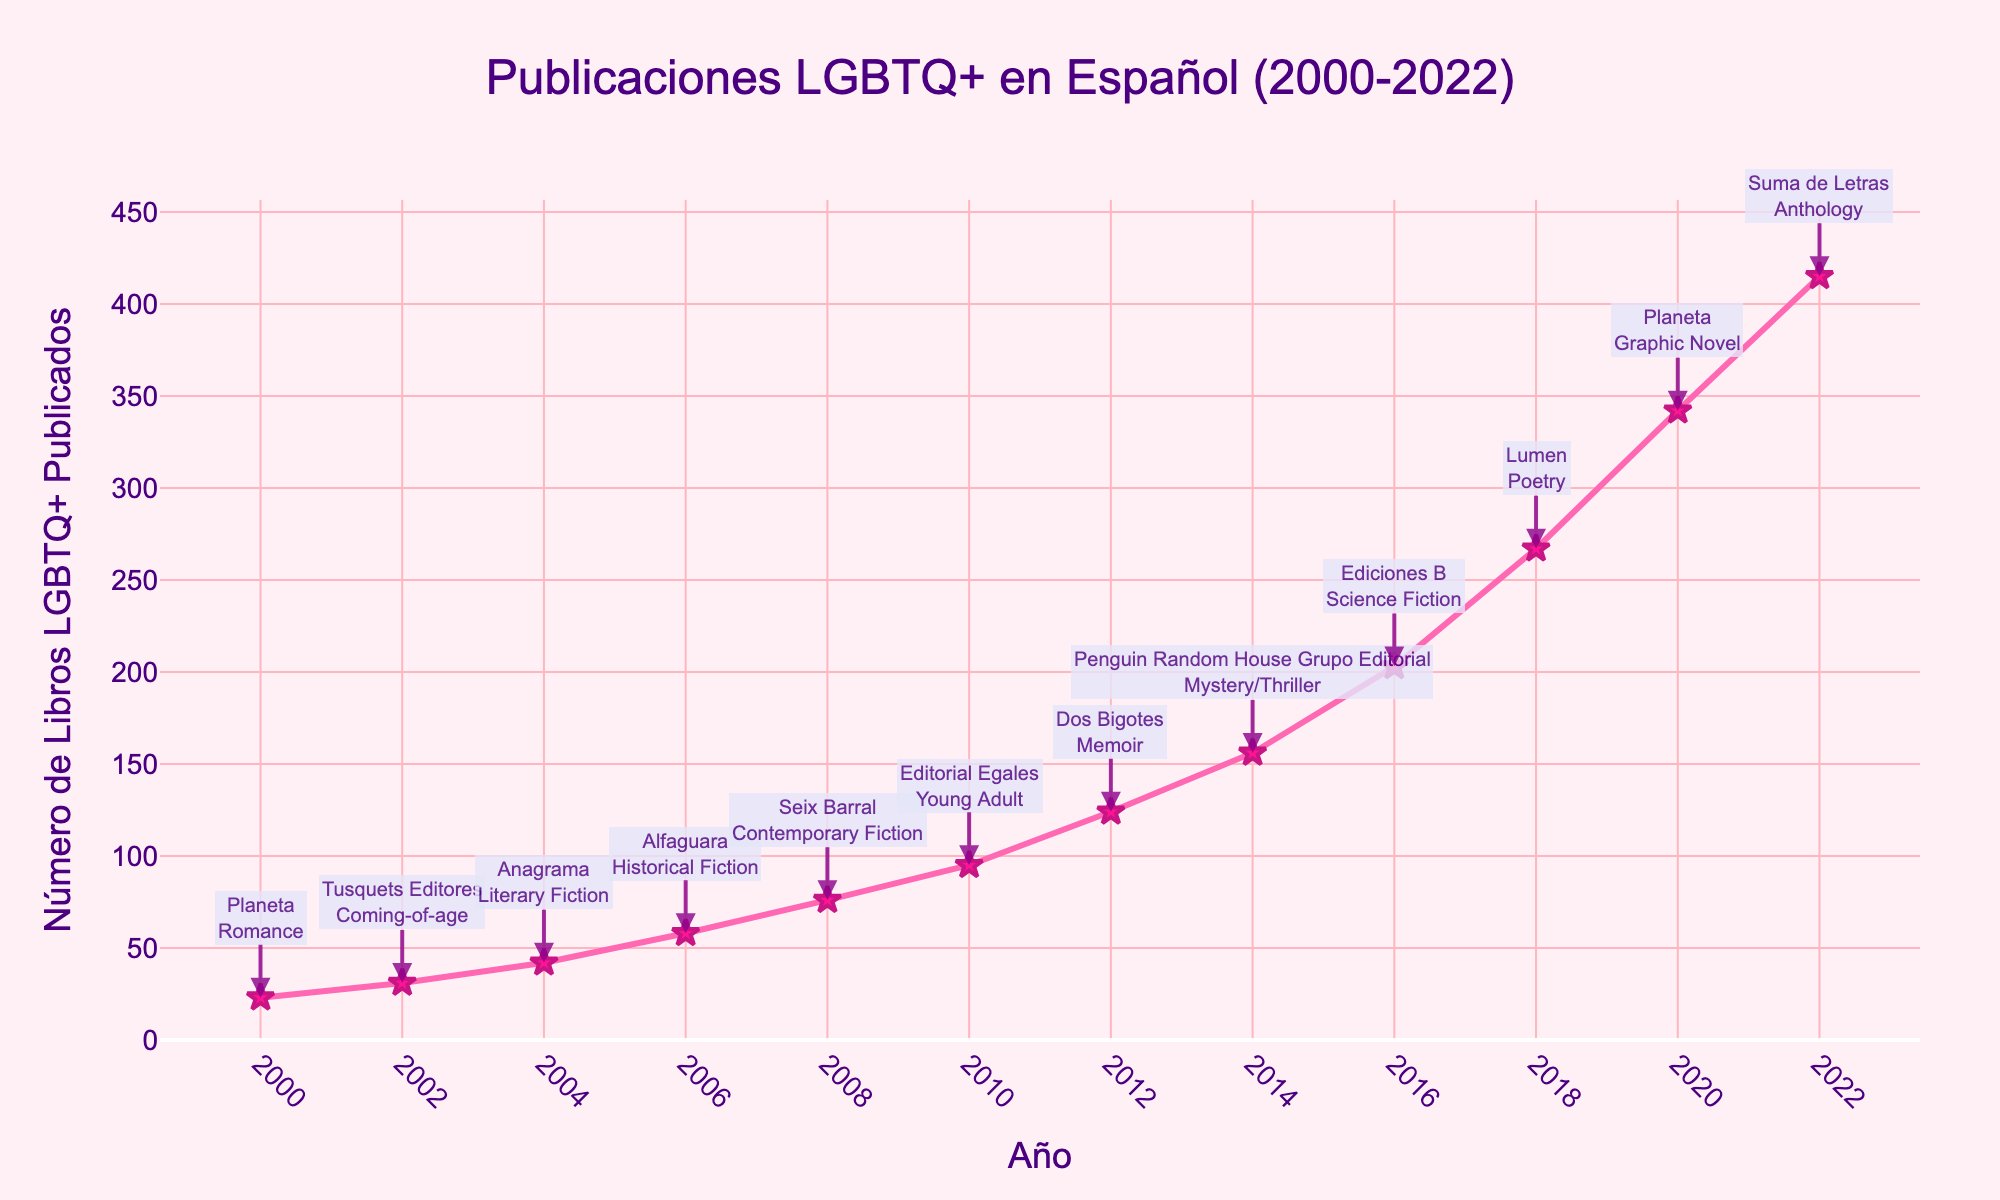What was the total number of LGBTQ+ books published between 2000 and 2010? To calculate this, sum the values from the years 2000 to 2010. The values are 23, 31, 42, 58, 76, 95. Therefore, the total is 23 + 31 + 42 + 58 + 76 + 95 = 325.
Answer: 325 In which year did the number of LGBTQ+ books published exceed 200 for the first time? Locate the year when the number of books published exceeded 200. The first year this happens is 2016, with 203 books published.
Answer: 2016 By how much did the number of LGBTQ+ books published increase from 2016 to 2018? Subtract the number of books published in 2016 from that in 2018. The values are 267 (2018) and 203 (2016). The increase is 267 - 203 = 64.
Answer: 64 Which year had the highest number of LGBTQ+ books published and which publisher was notable then? Identify the year with the highest value and the corresponding publisher. The year 2022 had the highest with 415 books, and the notable publisher was Suma de Letras.
Answer: 2022, Suma de Letras What are the most popular genres for the years 2002, 2010, and 2020? Check the annotation information for each of these years. In 2002, the genre was Coming-of-age; in 2010, it was Young Adult; in 2020, it was Graphic Novel.
Answer: Coming-of-age, Young Adult, Graphic Novel What is the average number of LGBTQ+ books published per year between 2008 and 2014? To find the average, sum the values from 2008 to 2014 and then divide by the number of years. The values are 76, 95, 124, 156. The sum is 76 + 95 + 124 + 156 = 451. There are 4 years, so the average is 451 / 4 = 112.75.
Answer: 112.75 How does the number of LGBTQ+ books published in 2010 compare with those in 2006 and 2012? Compare the values for these years. In 2010, 95 books were published, in 2006, 58 books, and in 2012, 124 books. Therefore, 2010 had more than 2006 but fewer than 2012.
Answer: More than 2006, fewer than 2012 What trend is noticeable in the number of LGBTQ+ books published from 2000 to 2022? Observing the plot, the trend shows a steady increase in the number of books published each year, with notable jumps in some years.
Answer: Steady increase Which year had the highest increase in the number of LGBTQ+ books published compared to the previous year? Calculate the yearly increases and identify the largest one. The largest increase is from 2020 to 2022: 415 - 342 = 73.
Answer: 2020 to 2022 Which color represents the line marking the number of LGBTQ+ books published, and what is its shape? The color of the line representing the number of books published is pink, and its shape includes lines and star-shaped markers.
Answer: Pink, star-shaped markers 